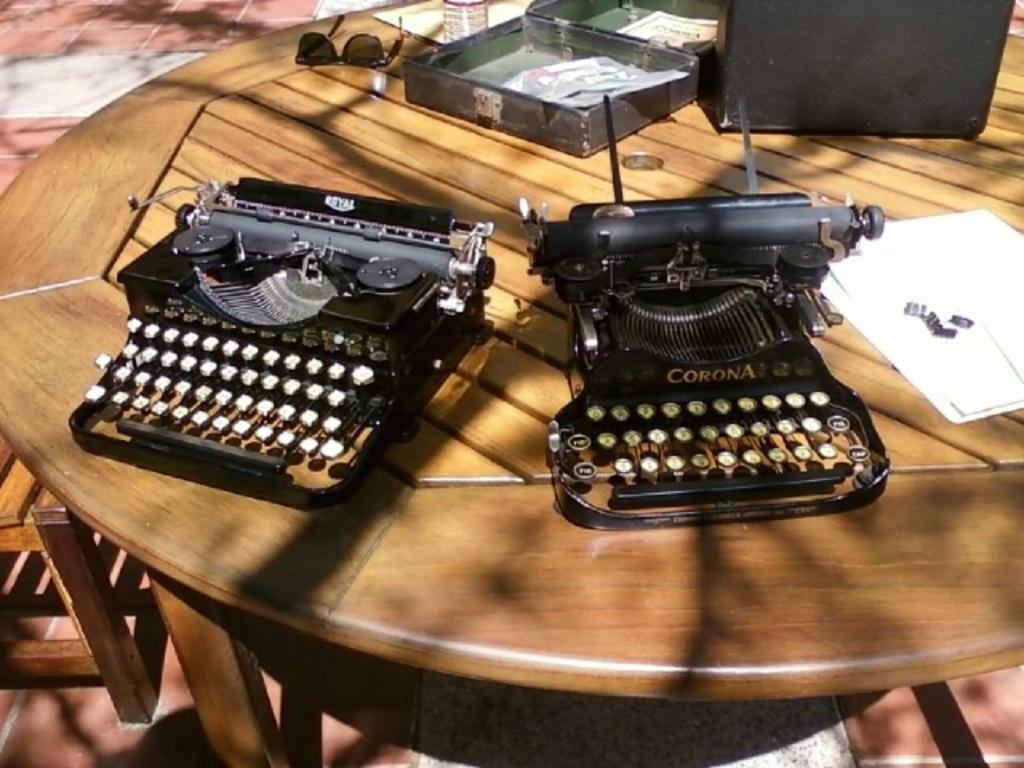Provide a one-sentence caption for the provided image. Two corona black and gold typewriters that are placed on a table. 